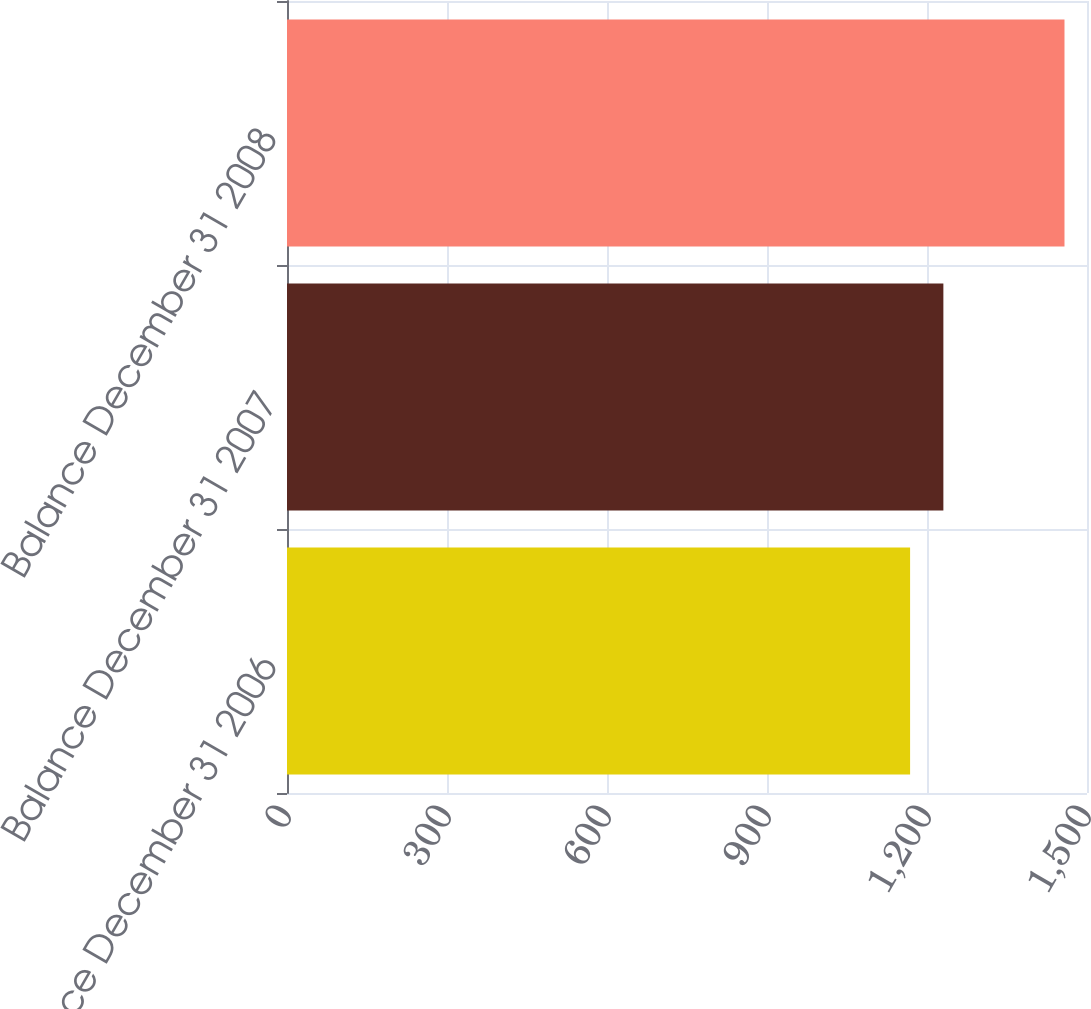<chart> <loc_0><loc_0><loc_500><loc_500><bar_chart><fcel>Balance December 31 2006<fcel>Balance December 31 2007<fcel>Balance December 31 2008<nl><fcel>1168.3<fcel>1230.7<fcel>1457.8<nl></chart> 